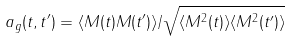<formula> <loc_0><loc_0><loc_500><loc_500>a _ { g } ( t , t ^ { \prime } ) = \langle M ( t ) M ( t ^ { \prime } ) \rangle / \sqrt { \langle M ^ { 2 } ( t ) \rangle \langle M ^ { 2 } ( t ^ { \prime } ) \rangle }</formula> 